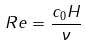<formula> <loc_0><loc_0><loc_500><loc_500>R e = \frac { c _ { 0 } H } { \nu } \,</formula> 